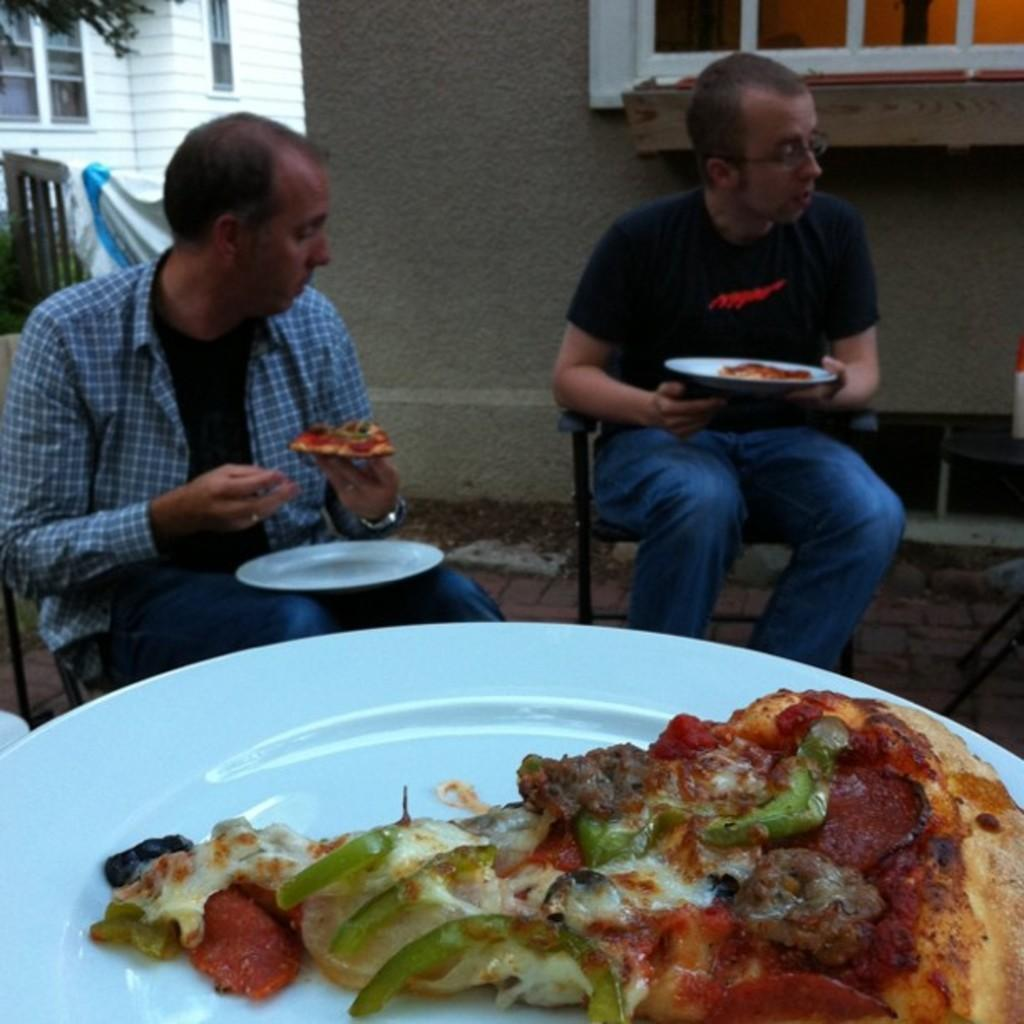How many people are sitting in the image? There are two men sitting in the image. What are the men holding in their hands? The men are holding plates in their hands. What can be seen on the plates? There is a plate and food visible in the image. What is visible in the background of the image? There are buildings and windows in the background of the image. What type of quill is the rabbit using to write a letter in the image? There is no rabbit or quill present in the image. What sound can be heard coming from the buildings in the background? The image is silent, so no sounds can be heard. 